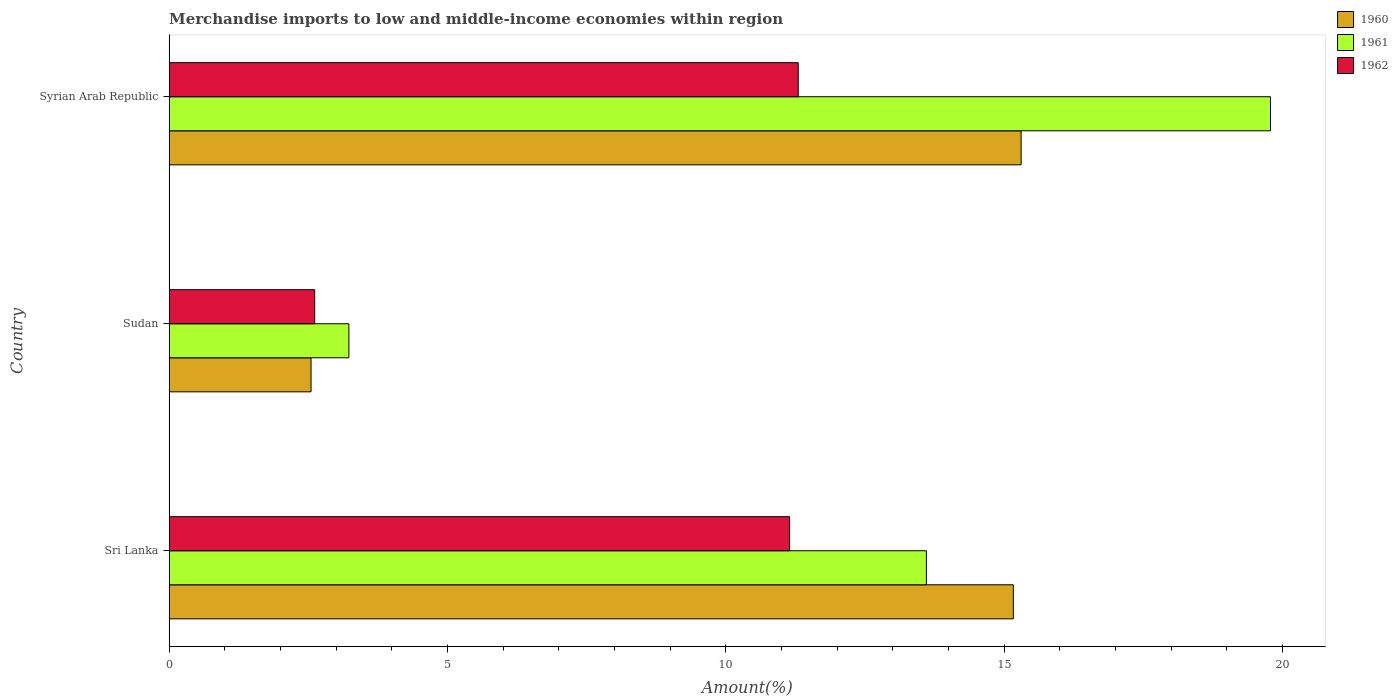How many groups of bars are there?
Make the answer very short. 3. How many bars are there on the 2nd tick from the bottom?
Your answer should be very brief. 3. What is the label of the 2nd group of bars from the top?
Provide a succinct answer. Sudan. What is the percentage of amount earned from merchandise imports in 1962 in Sri Lanka?
Make the answer very short. 11.15. Across all countries, what is the maximum percentage of amount earned from merchandise imports in 1961?
Offer a terse response. 19.79. Across all countries, what is the minimum percentage of amount earned from merchandise imports in 1960?
Your answer should be very brief. 2.55. In which country was the percentage of amount earned from merchandise imports in 1962 maximum?
Ensure brevity in your answer.  Syrian Arab Republic. In which country was the percentage of amount earned from merchandise imports in 1962 minimum?
Your response must be concise. Sudan. What is the total percentage of amount earned from merchandise imports in 1960 in the graph?
Your response must be concise. 33.02. What is the difference between the percentage of amount earned from merchandise imports in 1962 in Sri Lanka and that in Syrian Arab Republic?
Give a very brief answer. -0.16. What is the difference between the percentage of amount earned from merchandise imports in 1960 in Sri Lanka and the percentage of amount earned from merchandise imports in 1961 in Syrian Arab Republic?
Provide a short and direct response. -4.62. What is the average percentage of amount earned from merchandise imports in 1961 per country?
Provide a succinct answer. 12.21. What is the difference between the percentage of amount earned from merchandise imports in 1961 and percentage of amount earned from merchandise imports in 1962 in Syrian Arab Republic?
Provide a succinct answer. 8.49. In how many countries, is the percentage of amount earned from merchandise imports in 1962 greater than 13 %?
Your answer should be compact. 0. What is the ratio of the percentage of amount earned from merchandise imports in 1961 in Sri Lanka to that in Sudan?
Ensure brevity in your answer.  4.21. Is the percentage of amount earned from merchandise imports in 1961 in Sri Lanka less than that in Syrian Arab Republic?
Make the answer very short. Yes. What is the difference between the highest and the second highest percentage of amount earned from merchandise imports in 1962?
Offer a very short reply. 0.16. What is the difference between the highest and the lowest percentage of amount earned from merchandise imports in 1962?
Provide a succinct answer. 8.69. Is the sum of the percentage of amount earned from merchandise imports in 1962 in Sri Lanka and Syrian Arab Republic greater than the maximum percentage of amount earned from merchandise imports in 1960 across all countries?
Give a very brief answer. Yes. What does the 1st bar from the top in Sri Lanka represents?
Provide a short and direct response. 1962. What does the 2nd bar from the bottom in Sri Lanka represents?
Ensure brevity in your answer.  1961. Is it the case that in every country, the sum of the percentage of amount earned from merchandise imports in 1961 and percentage of amount earned from merchandise imports in 1960 is greater than the percentage of amount earned from merchandise imports in 1962?
Keep it short and to the point. Yes. How many bars are there?
Ensure brevity in your answer.  9. How many countries are there in the graph?
Your response must be concise. 3. Are the values on the major ticks of X-axis written in scientific E-notation?
Your answer should be compact. No. Does the graph contain any zero values?
Your answer should be compact. No. Does the graph contain grids?
Make the answer very short. No. Where does the legend appear in the graph?
Your answer should be very brief. Top right. How many legend labels are there?
Provide a short and direct response. 3. What is the title of the graph?
Offer a very short reply. Merchandise imports to low and middle-income economies within region. What is the label or title of the X-axis?
Your response must be concise. Amount(%). What is the label or title of the Y-axis?
Your answer should be very brief. Country. What is the Amount(%) in 1960 in Sri Lanka?
Your answer should be compact. 15.17. What is the Amount(%) in 1961 in Sri Lanka?
Your answer should be compact. 13.6. What is the Amount(%) in 1962 in Sri Lanka?
Offer a terse response. 11.15. What is the Amount(%) of 1960 in Sudan?
Offer a terse response. 2.55. What is the Amount(%) in 1961 in Sudan?
Offer a very short reply. 3.23. What is the Amount(%) in 1962 in Sudan?
Keep it short and to the point. 2.61. What is the Amount(%) in 1960 in Syrian Arab Republic?
Offer a very short reply. 15.31. What is the Amount(%) of 1961 in Syrian Arab Republic?
Your answer should be compact. 19.79. What is the Amount(%) in 1962 in Syrian Arab Republic?
Your answer should be very brief. 11.3. Across all countries, what is the maximum Amount(%) in 1960?
Ensure brevity in your answer.  15.31. Across all countries, what is the maximum Amount(%) in 1961?
Your answer should be compact. 19.79. Across all countries, what is the maximum Amount(%) of 1962?
Make the answer very short. 11.3. Across all countries, what is the minimum Amount(%) in 1960?
Give a very brief answer. 2.55. Across all countries, what is the minimum Amount(%) of 1961?
Your answer should be very brief. 3.23. Across all countries, what is the minimum Amount(%) in 1962?
Provide a succinct answer. 2.61. What is the total Amount(%) of 1960 in the graph?
Your answer should be very brief. 33.02. What is the total Amount(%) of 1961 in the graph?
Keep it short and to the point. 36.62. What is the total Amount(%) of 1962 in the graph?
Give a very brief answer. 25.06. What is the difference between the Amount(%) of 1960 in Sri Lanka and that in Sudan?
Ensure brevity in your answer.  12.62. What is the difference between the Amount(%) of 1961 in Sri Lanka and that in Sudan?
Your answer should be very brief. 10.38. What is the difference between the Amount(%) in 1962 in Sri Lanka and that in Sudan?
Your answer should be compact. 8.53. What is the difference between the Amount(%) in 1960 in Sri Lanka and that in Syrian Arab Republic?
Provide a short and direct response. -0.14. What is the difference between the Amount(%) of 1961 in Sri Lanka and that in Syrian Arab Republic?
Ensure brevity in your answer.  -6.18. What is the difference between the Amount(%) of 1962 in Sri Lanka and that in Syrian Arab Republic?
Keep it short and to the point. -0.16. What is the difference between the Amount(%) of 1960 in Sudan and that in Syrian Arab Republic?
Ensure brevity in your answer.  -12.76. What is the difference between the Amount(%) of 1961 in Sudan and that in Syrian Arab Republic?
Provide a short and direct response. -16.56. What is the difference between the Amount(%) in 1962 in Sudan and that in Syrian Arab Republic?
Your answer should be very brief. -8.69. What is the difference between the Amount(%) in 1960 in Sri Lanka and the Amount(%) in 1961 in Sudan?
Make the answer very short. 11.94. What is the difference between the Amount(%) in 1960 in Sri Lanka and the Amount(%) in 1962 in Sudan?
Your answer should be compact. 12.55. What is the difference between the Amount(%) of 1961 in Sri Lanka and the Amount(%) of 1962 in Sudan?
Provide a succinct answer. 10.99. What is the difference between the Amount(%) of 1960 in Sri Lanka and the Amount(%) of 1961 in Syrian Arab Republic?
Keep it short and to the point. -4.62. What is the difference between the Amount(%) in 1960 in Sri Lanka and the Amount(%) in 1962 in Syrian Arab Republic?
Your answer should be compact. 3.87. What is the difference between the Amount(%) of 1961 in Sri Lanka and the Amount(%) of 1962 in Syrian Arab Republic?
Make the answer very short. 2.3. What is the difference between the Amount(%) in 1960 in Sudan and the Amount(%) in 1961 in Syrian Arab Republic?
Your answer should be compact. -17.24. What is the difference between the Amount(%) in 1960 in Sudan and the Amount(%) in 1962 in Syrian Arab Republic?
Your response must be concise. -8.75. What is the difference between the Amount(%) in 1961 in Sudan and the Amount(%) in 1962 in Syrian Arab Republic?
Provide a short and direct response. -8.07. What is the average Amount(%) in 1960 per country?
Ensure brevity in your answer.  11.01. What is the average Amount(%) in 1961 per country?
Offer a terse response. 12.21. What is the average Amount(%) of 1962 per country?
Your response must be concise. 8.35. What is the difference between the Amount(%) in 1960 and Amount(%) in 1961 in Sri Lanka?
Provide a succinct answer. 1.56. What is the difference between the Amount(%) of 1960 and Amount(%) of 1962 in Sri Lanka?
Your response must be concise. 4.02. What is the difference between the Amount(%) of 1961 and Amount(%) of 1962 in Sri Lanka?
Keep it short and to the point. 2.46. What is the difference between the Amount(%) in 1960 and Amount(%) in 1961 in Sudan?
Offer a very short reply. -0.68. What is the difference between the Amount(%) of 1960 and Amount(%) of 1962 in Sudan?
Your answer should be very brief. -0.07. What is the difference between the Amount(%) of 1961 and Amount(%) of 1962 in Sudan?
Provide a succinct answer. 0.61. What is the difference between the Amount(%) in 1960 and Amount(%) in 1961 in Syrian Arab Republic?
Provide a succinct answer. -4.48. What is the difference between the Amount(%) in 1960 and Amount(%) in 1962 in Syrian Arab Republic?
Provide a succinct answer. 4.01. What is the difference between the Amount(%) in 1961 and Amount(%) in 1962 in Syrian Arab Republic?
Offer a very short reply. 8.49. What is the ratio of the Amount(%) in 1960 in Sri Lanka to that in Sudan?
Your answer should be compact. 5.95. What is the ratio of the Amount(%) in 1961 in Sri Lanka to that in Sudan?
Keep it short and to the point. 4.21. What is the ratio of the Amount(%) in 1962 in Sri Lanka to that in Sudan?
Offer a terse response. 4.26. What is the ratio of the Amount(%) of 1960 in Sri Lanka to that in Syrian Arab Republic?
Provide a short and direct response. 0.99. What is the ratio of the Amount(%) of 1961 in Sri Lanka to that in Syrian Arab Republic?
Provide a short and direct response. 0.69. What is the ratio of the Amount(%) in 1962 in Sri Lanka to that in Syrian Arab Republic?
Keep it short and to the point. 0.99. What is the ratio of the Amount(%) of 1960 in Sudan to that in Syrian Arab Republic?
Your response must be concise. 0.17. What is the ratio of the Amount(%) of 1961 in Sudan to that in Syrian Arab Republic?
Your response must be concise. 0.16. What is the ratio of the Amount(%) of 1962 in Sudan to that in Syrian Arab Republic?
Your answer should be very brief. 0.23. What is the difference between the highest and the second highest Amount(%) of 1960?
Your answer should be compact. 0.14. What is the difference between the highest and the second highest Amount(%) in 1961?
Provide a succinct answer. 6.18. What is the difference between the highest and the second highest Amount(%) in 1962?
Keep it short and to the point. 0.16. What is the difference between the highest and the lowest Amount(%) of 1960?
Give a very brief answer. 12.76. What is the difference between the highest and the lowest Amount(%) in 1961?
Keep it short and to the point. 16.56. What is the difference between the highest and the lowest Amount(%) of 1962?
Your answer should be compact. 8.69. 